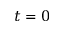Convert formula to latex. <formula><loc_0><loc_0><loc_500><loc_500>t = 0</formula> 